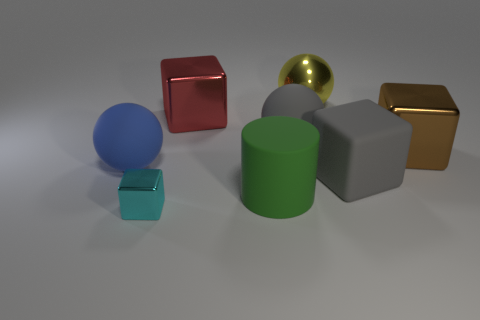Add 1 blue matte objects. How many objects exist? 9 Subtract all spheres. How many objects are left? 5 Add 7 big red cubes. How many big red cubes are left? 8 Add 8 tiny things. How many tiny things exist? 9 Subtract 1 green cylinders. How many objects are left? 7 Subtract all large shiny cubes. Subtract all green cylinders. How many objects are left? 5 